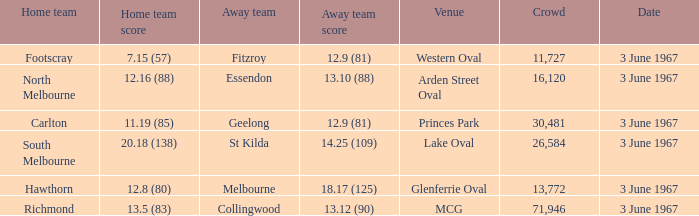What was Hawthorn's score as the home team? 12.8 (80). 